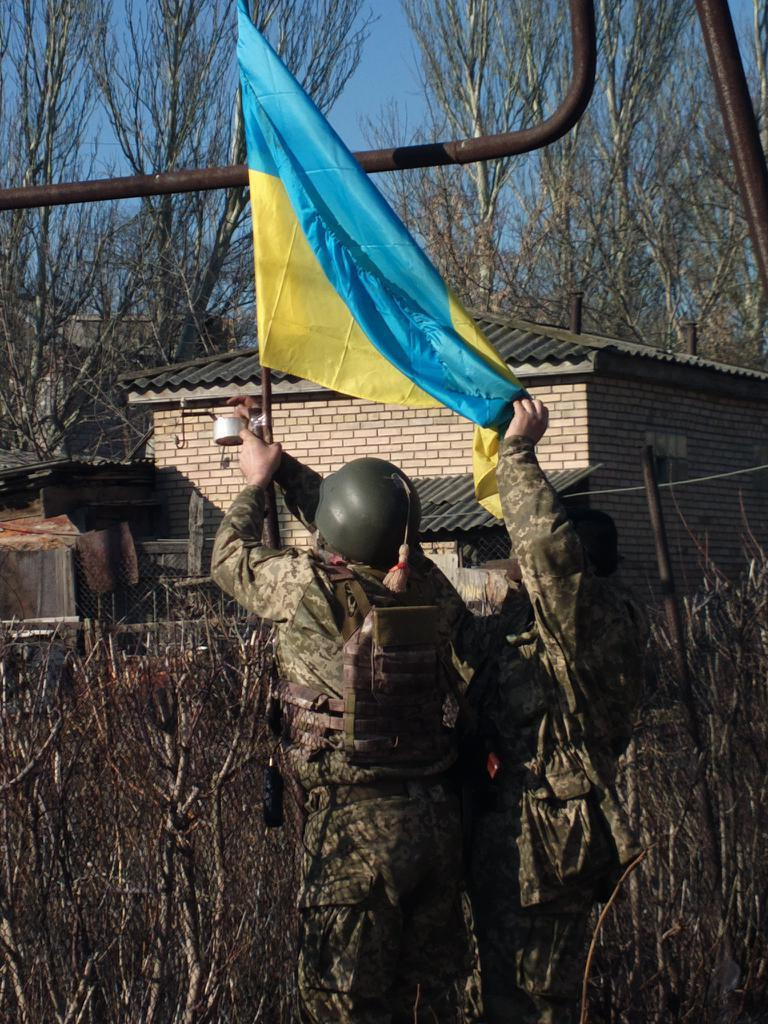What type of protective gear can be seen in the image? There is a helmet in the image. What object is used for carrying items in the image? There is a bag in the image. What type of natural vegetation is present in the image? There are trees in the image. What type of man-made structure is present in the image? There is a building in the image. What are two people doing in the image? Two people are holding a flag in the image. What other objects can be seen in the image? There are some objects in the image. What can be seen in the background of the image? The sky is visible in the background of the image. What type of gate is present in the image? There is no gate present in the image. 